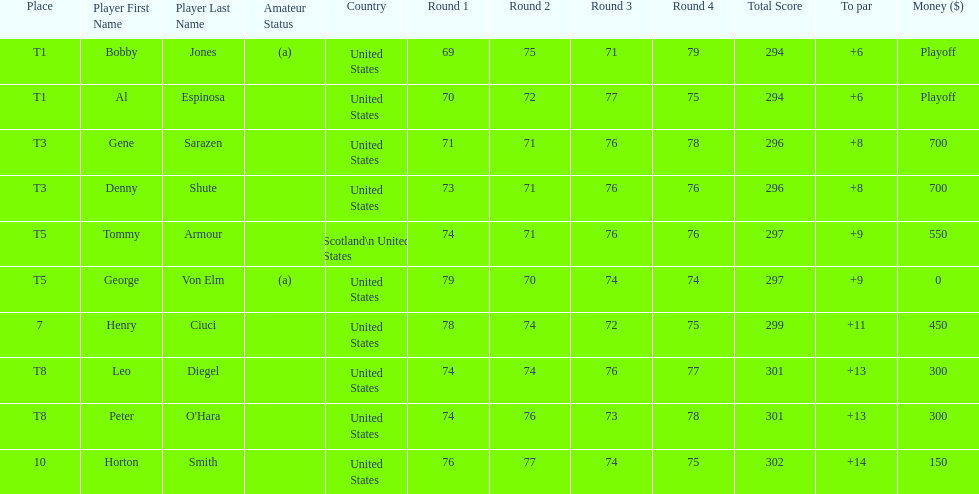Did tommy armour place above or below denny shute? Below. 